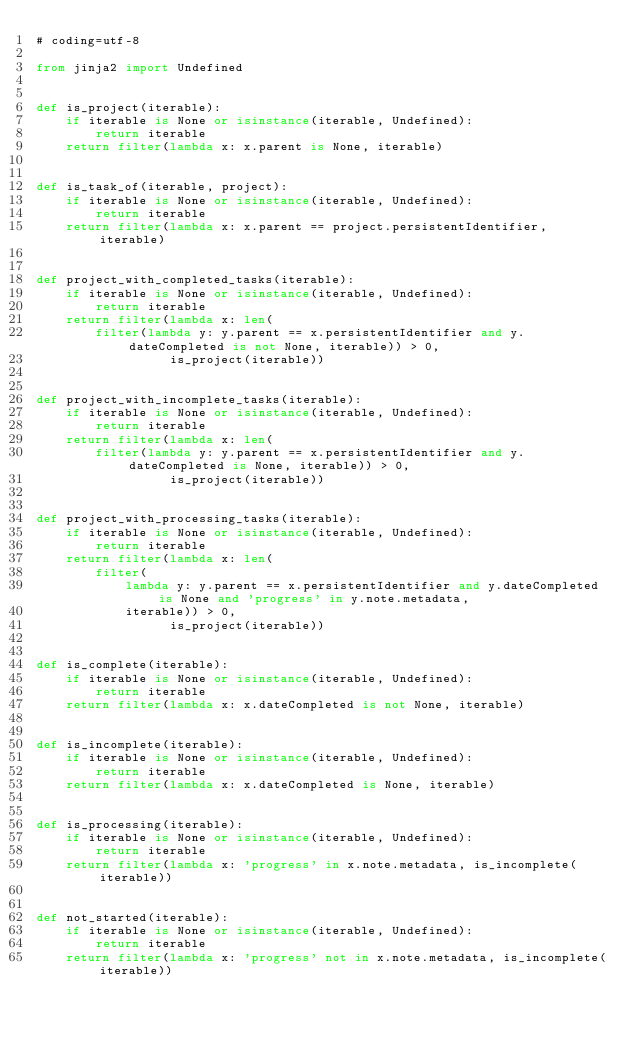Convert code to text. <code><loc_0><loc_0><loc_500><loc_500><_Python_># coding=utf-8

from jinja2 import Undefined


def is_project(iterable):
    if iterable is None or isinstance(iterable, Undefined):
        return iterable
    return filter(lambda x: x.parent is None, iterable)


def is_task_of(iterable, project):
    if iterable is None or isinstance(iterable, Undefined):
        return iterable
    return filter(lambda x: x.parent == project.persistentIdentifier, iterable)


def project_with_completed_tasks(iterable):
    if iterable is None or isinstance(iterable, Undefined):
        return iterable
    return filter(lambda x: len(
        filter(lambda y: y.parent == x.persistentIdentifier and y.dateCompleted is not None, iterable)) > 0,
                  is_project(iterable))


def project_with_incomplete_tasks(iterable):
    if iterable is None or isinstance(iterable, Undefined):
        return iterable
    return filter(lambda x: len(
        filter(lambda y: y.parent == x.persistentIdentifier and y.dateCompleted is None, iterable)) > 0,
                  is_project(iterable))


def project_with_processing_tasks(iterable):
    if iterable is None or isinstance(iterable, Undefined):
        return iterable
    return filter(lambda x: len(
        filter(
            lambda y: y.parent == x.persistentIdentifier and y.dateCompleted is None and 'progress' in y.note.metadata,
            iterable)) > 0,
                  is_project(iterable))


def is_complete(iterable):
    if iterable is None or isinstance(iterable, Undefined):
        return iterable
    return filter(lambda x: x.dateCompleted is not None, iterable)


def is_incomplete(iterable):
    if iterable is None or isinstance(iterable, Undefined):
        return iterable
    return filter(lambda x: x.dateCompleted is None, iterable)


def is_processing(iterable):
    if iterable is None or isinstance(iterable, Undefined):
        return iterable
    return filter(lambda x: 'progress' in x.note.metadata, is_incomplete(iterable))


def not_started(iterable):
    if iterable is None or isinstance(iterable, Undefined):
        return iterable
    return filter(lambda x: 'progress' not in x.note.metadata, is_incomplete(iterable))
</code> 